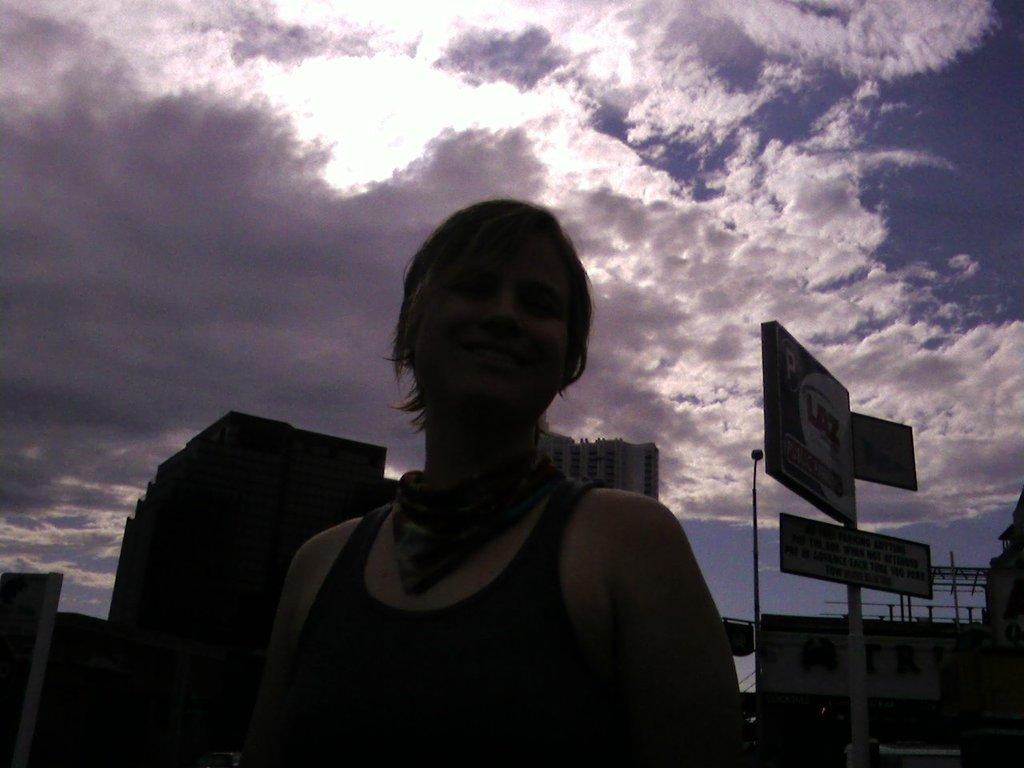Who is present in the image? There is a woman in the image. What is the woman doing in the image? The woman is standing and smiling. What can be seen in the background of the image? There are buildings, a hoarding, and a pole in the background of the image. What is the weather like in the image? The sky is cloudy in the image. How many beds can be seen in the image? There are no beds present in the image. What is the process being carried out by the woman in the image? The woman is not performing any process in the image; she is simply standing and smiling. 